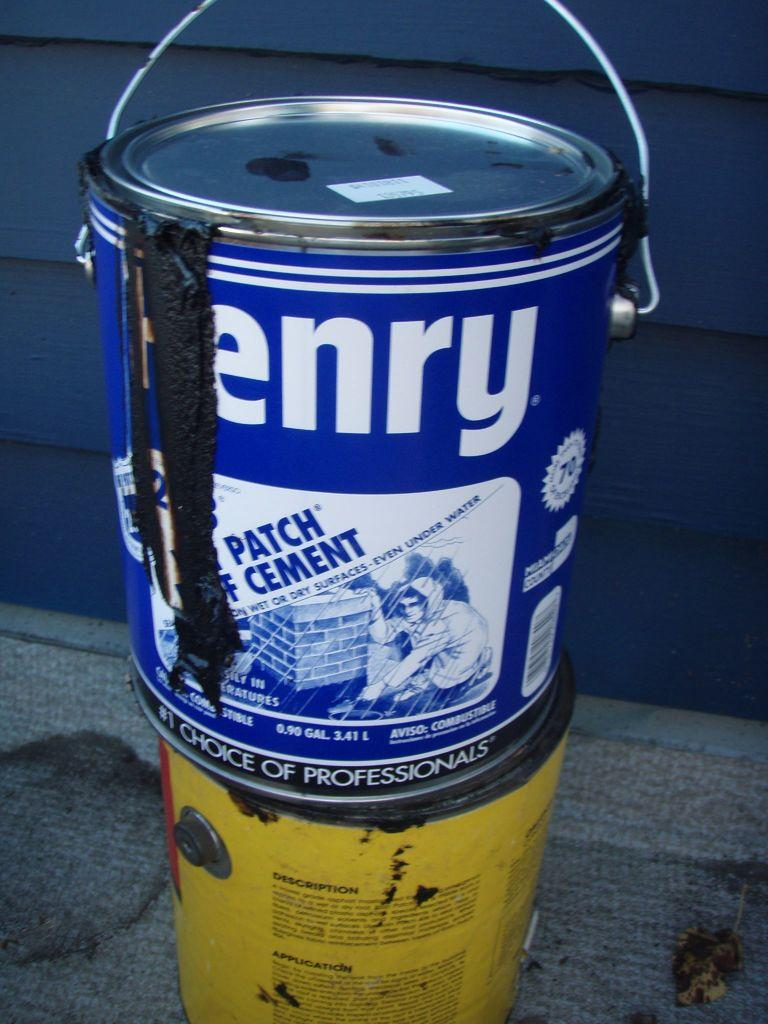<image>
Render a clear and concise summary of the photo. a paint bottle with the word henry on it 